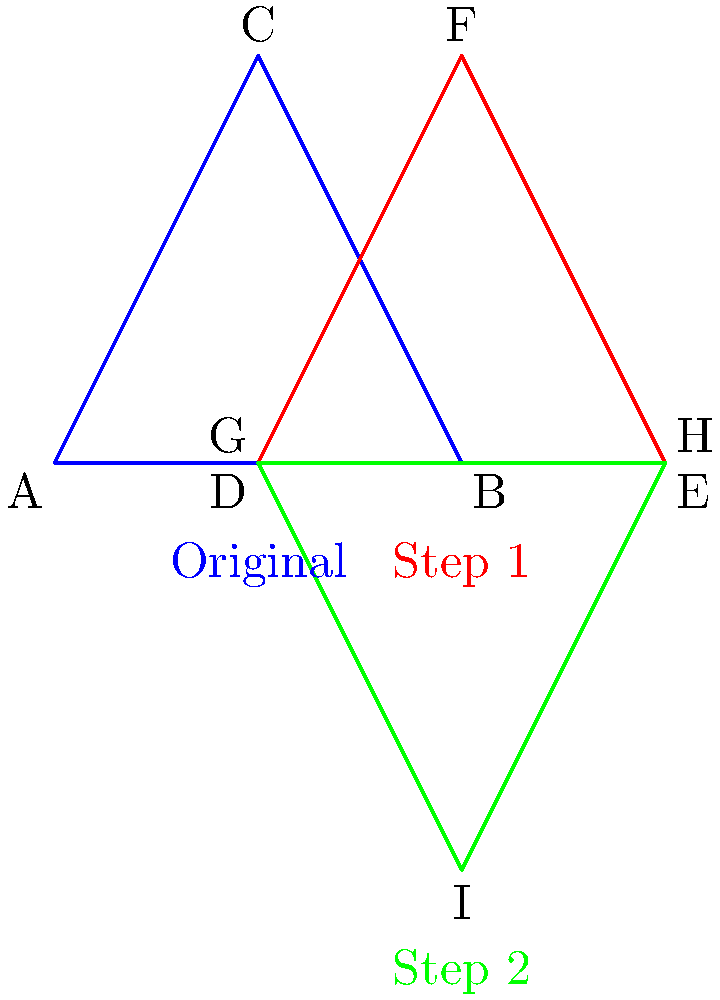As a software engineer familiar with transformational geometry, analyze the sequence of transformations applied to the blue triangle ABC to obtain the green triangle GHI. What is the composition of these transformations? Let's break this down step-by-step:

1. First, observe the transformation from the blue triangle ABC to the red triangle DEF:
   - This is a translation. The triangle has moved 1 unit to the right.
   - We can represent this as $T_{(1,0)}$, where $T$ denotes translation.

2. Now, look at the transformation from the red triangle DEF to the green triangle GHI:
   - This is a reflection. The triangle has been flipped over the x-axis.
   - We can represent this as $R_x$, where $R_x$ denotes reflection over the x-axis.

3. To get the composition of these transformations, we apply them in order:
   - First, we translate: $T_{(1,0)}$
   - Then, we reflect: $R_x$

4. In transformation composition, we write these from right to left. So the final composition is:
   $R_x \circ T_{(1,0)}$

This means "first translate by (1,0), then reflect over the x-axis".

As a software engineer, you might think of this as function composition, where the output of the first function (translation) becomes the input of the second function (reflection).
Answer: $R_x \circ T_{(1,0)}$ 